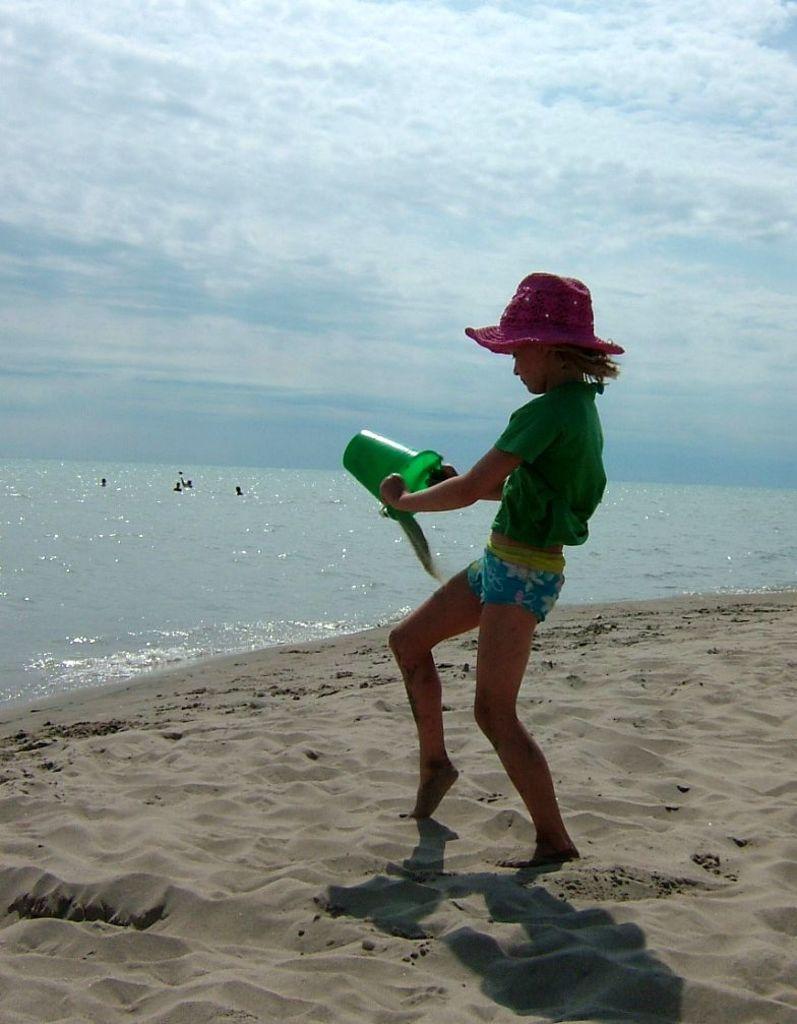How would you summarize this image in a sentence or two? In the center of the image a girl is standing and holding an object in her hand and wearing a hat. In the middle of the image water is present. At the bottom of the image soil is there. At the top of the image clouds are present in the sky. 